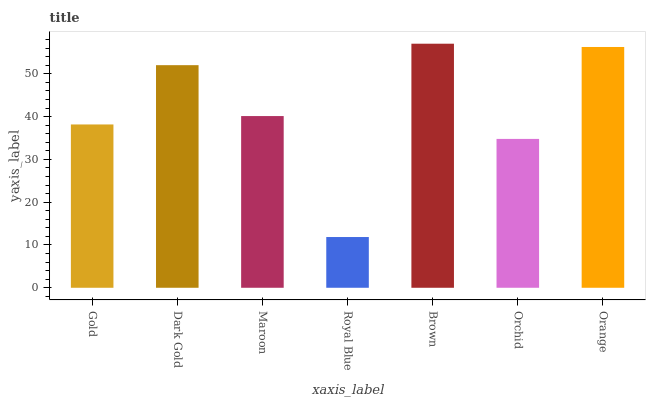Is Royal Blue the minimum?
Answer yes or no. Yes. Is Brown the maximum?
Answer yes or no. Yes. Is Dark Gold the minimum?
Answer yes or no. No. Is Dark Gold the maximum?
Answer yes or no. No. Is Dark Gold greater than Gold?
Answer yes or no. Yes. Is Gold less than Dark Gold?
Answer yes or no. Yes. Is Gold greater than Dark Gold?
Answer yes or no. No. Is Dark Gold less than Gold?
Answer yes or no. No. Is Maroon the high median?
Answer yes or no. Yes. Is Maroon the low median?
Answer yes or no. Yes. Is Royal Blue the high median?
Answer yes or no. No. Is Dark Gold the low median?
Answer yes or no. No. 